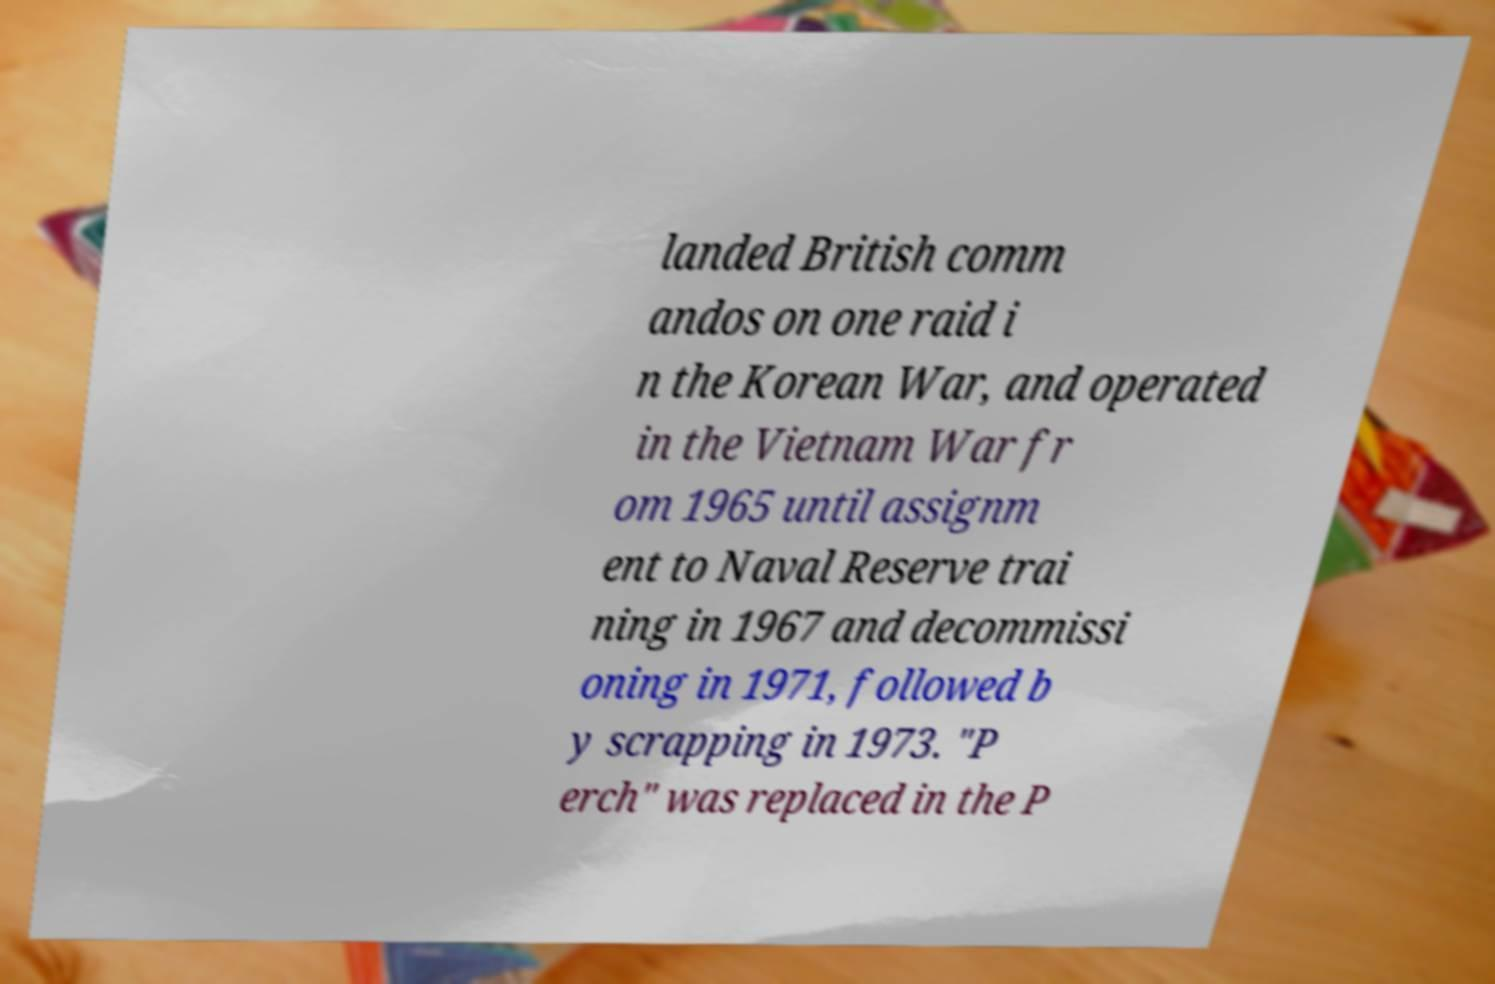What messages or text are displayed in this image? I need them in a readable, typed format. landed British comm andos on one raid i n the Korean War, and operated in the Vietnam War fr om 1965 until assignm ent to Naval Reserve trai ning in 1967 and decommissi oning in 1971, followed b y scrapping in 1973. "P erch" was replaced in the P 